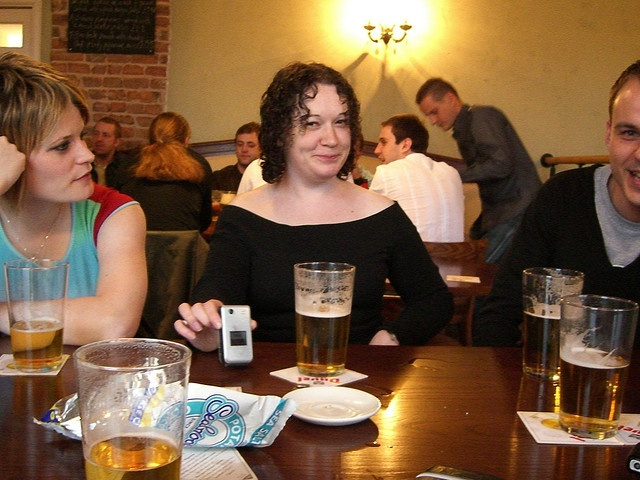Describe the objects in this image and their specific colors. I can see dining table in brown, maroon, black, and lightgray tones, people in brown, black, tan, and maroon tones, people in brown, tan, gray, and maroon tones, people in brown, black, gray, and maroon tones, and cup in brown, lightgray, gray, darkgray, and tan tones in this image. 